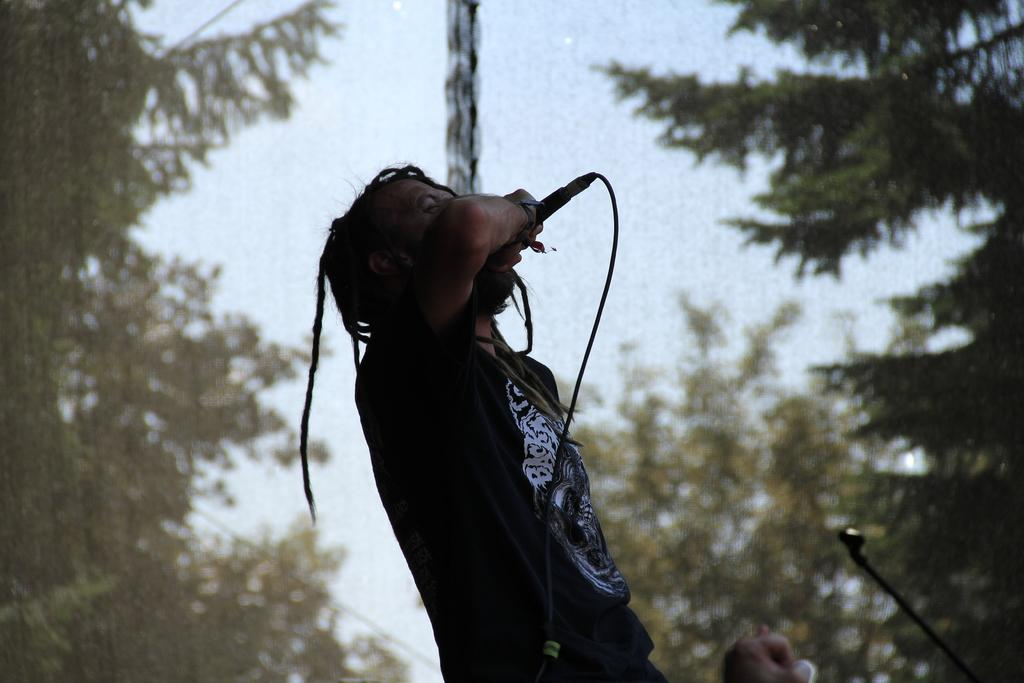What is the man in the image wearing? The man is wearing a black shirt. What is the man holding in his right hand? The man is holding a microphone in his right hand. What is the man doing in the image? The man is singing a song. Where is the image set? The setting is an open area. What can be seen in the background of the image? There is sky and trees visible in the background of the image. What type of orange is being used to fill the basin in the image? There is no orange or basin present in the image. How is the man's shirt being burned in the image? The man's shirt is not being burned in the image; he is wearing a black shirt. 